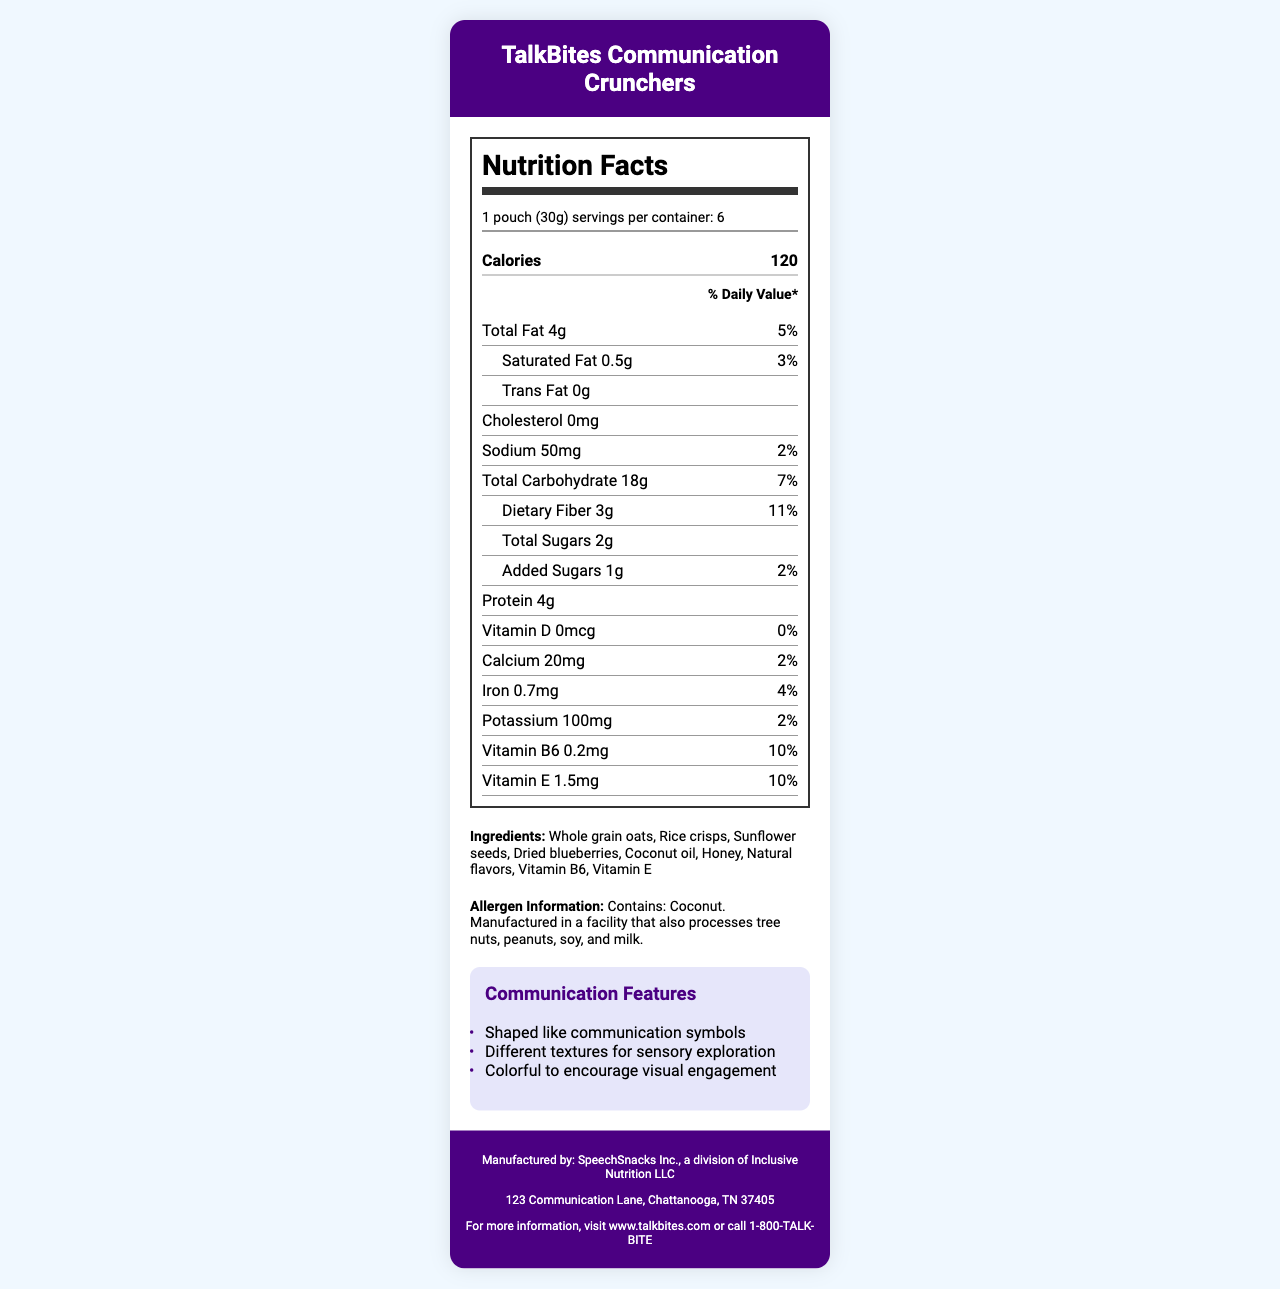who manufactures TalkBites Communication Crunchers? The footer of the document specifies that the product is manufactured by SpeechSnacks Inc., a division of Inclusive Nutrition LLC.
Answer: SpeechSnacks Inc., a division of Inclusive Nutrition LLC how many servings of TalkBites Communication Crunchers are in one container? The serving information mentions that there are 6 servings per container.
Answer: 6 what is the calorie content per serving of TalkBites Communication Crunchers? The nutritional label shows that each serving contains 120 calories.
Answer: 120 list three main ingredients in TalkBites Communication Crunchers. The ingredients list includes these items prominently at the beginning.
Answer: Whole grain oats, Rice crisps, Sunflower seeds does TalkBites Communication Crunchers contain any added sugars? The nutritional label indicates that there is 1g of added sugars per serving.
Answer: Yes how much protein is in one serving of TalkBites Communication Crunchers? The nutrition facts section lists the protein content as 4g per serving.
Answer: 4g is TalkBites Communication Crunchers gluten-free? The document mentions that the product is gluten-free.
Answer: Yes what is the serving size of TalkBites Communication Crunchers? A. 20g B. 30g C. 40g The serving size is specified as "1 pouch (30g)" in the nutritional label.
Answer: B. 30g which vitamin has the highest daily value percentage in TalkBites Communication Crunchers? I. Vitamin D II. Vitamin B6 III. Vitamin E The daily value percentage for Vitamin B6 is 10%, which is the highest among the vitamins listed.
Answer: II. Vitamin B6 what feature makes TalkBites Communication Crunchers a sensory-friendly snack? A. High-fat content B. Different textures C. Contains peanuts D. Low-calorie The document highlights that the snack has different textures for sensory exploration.
Answer: B. Different textures is TalkBites Communication Crunchers endorsed by speech therapists? The document specifically mentions that the product is speech therapist endorsed.
Answer: Yes what is the address of the manufacturer? The address is provided in the footer under the manufacturer's information.
Answer: 123 Communication Lane, Chattanooga, TN 37405 summarize the main features of TalkBites Communication Crunchers. The document provides detailed nutritional information, ingredients list, and key features designed to promote communication and sensory engagement among non-verbal children. It also emphasizes the product's suitability by being gluten-free, non-GMO, and endorsed by speech therapists.
Answer: TalkBites Communication Crunchers are a sensory-friendly snack designed for non-verbal children. Each serving is 30g, providing 120 calories. The product includes whole grain oats, rice crisps, and sunflower seeds, with added vitamins B6 and E. It is gluten-free, non-GMO, and endorsed by speech therapists. The snack has communication features like different textures and communication symbol shapes. how should TalkBites Communication Crunchers be stored? The storage instructions specify the need to store the product in a cool, dry place and consume it within 3 days of opening.
Answer: Store in a cool, dry place. Consume within 3 days of opening. are TalkBites Communication Crunchers organic? The document mentions that the product is not organic.
Answer: No does the product contain any tree nuts? The allergen information says it is manufactured in a facility that processes tree nuts, but it does not confirm if the product itself contains tree nuts.
Answer: Cannot be determined 